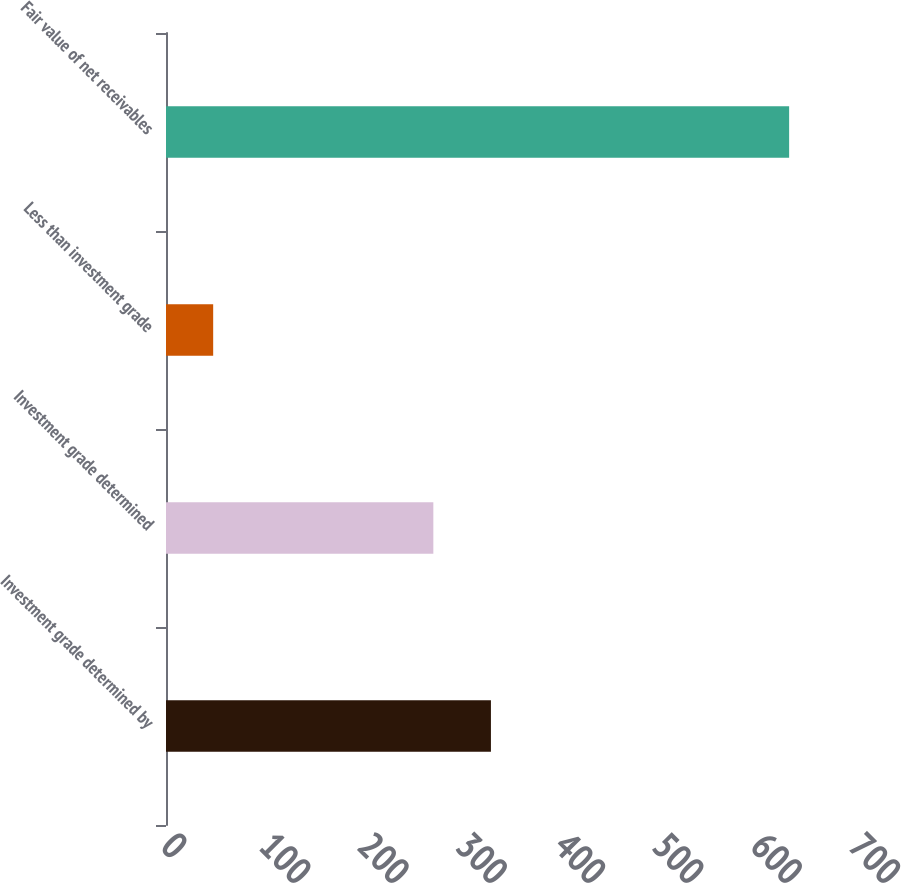<chart> <loc_0><loc_0><loc_500><loc_500><bar_chart><fcel>Investment grade determined by<fcel>Investment grade determined<fcel>Less than investment grade<fcel>Fair value of net receivables<nl><fcel>330.6<fcel>272<fcel>48<fcel>634<nl></chart> 